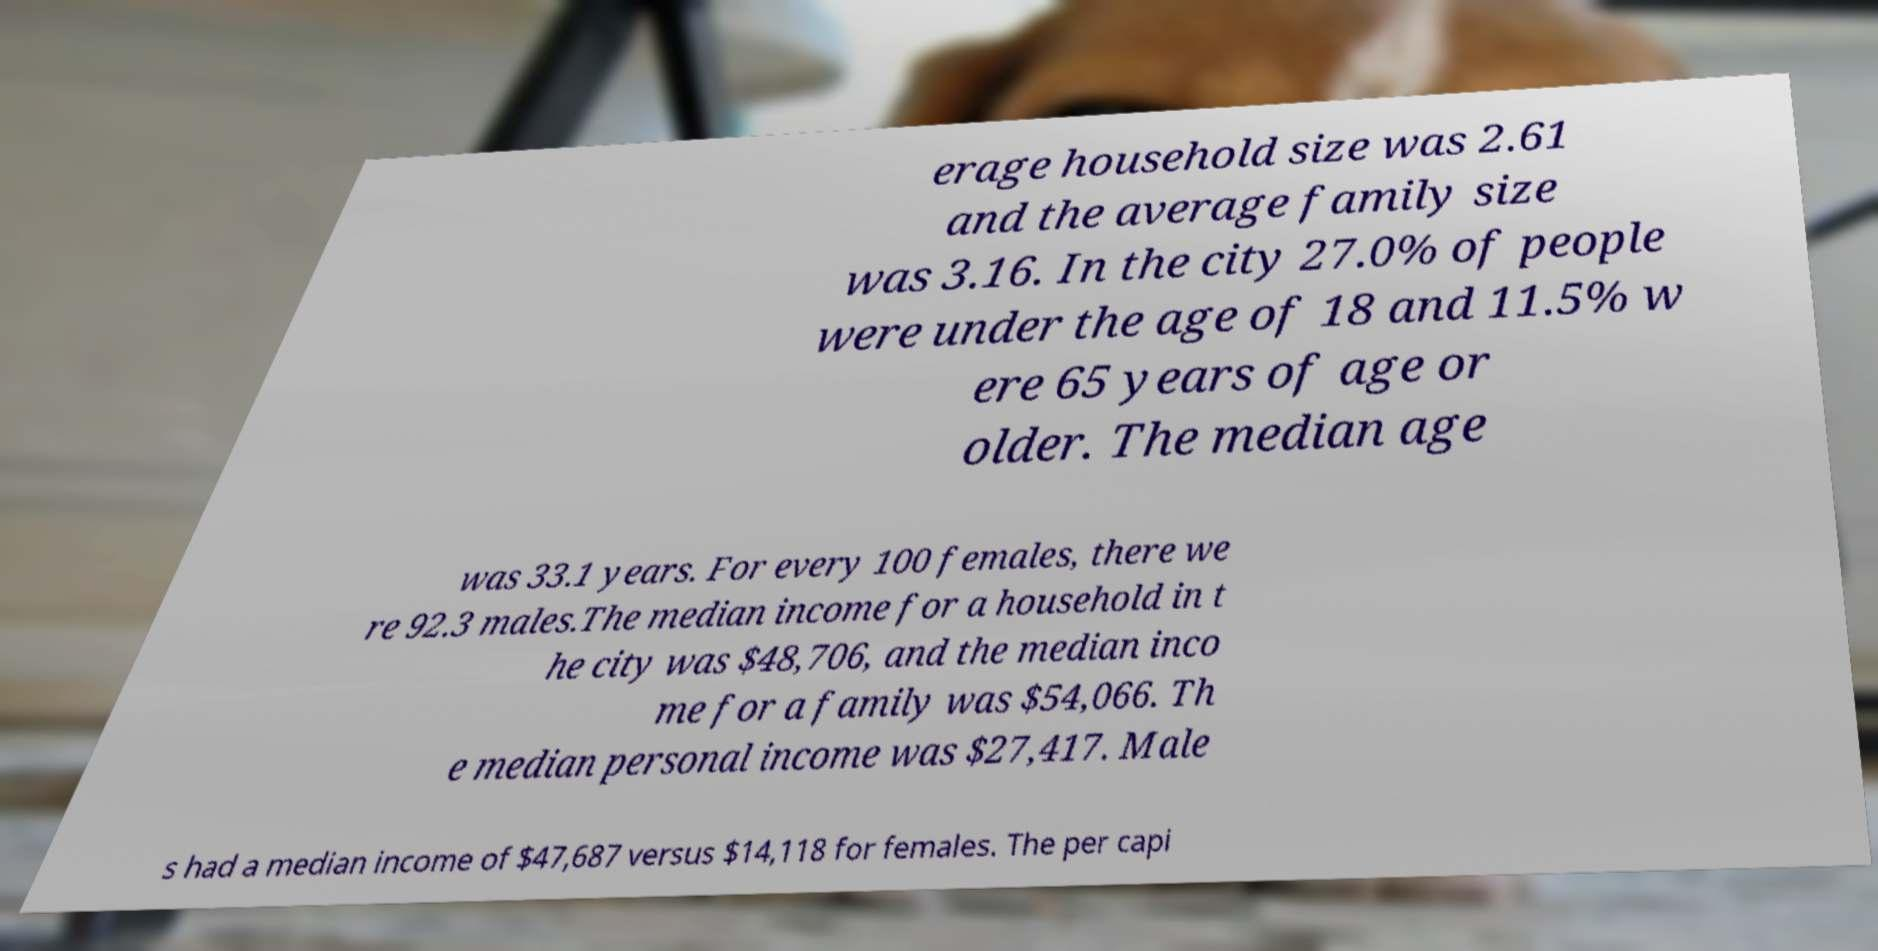What messages or text are displayed in this image? I need them in a readable, typed format. erage household size was 2.61 and the average family size was 3.16. In the city 27.0% of people were under the age of 18 and 11.5% w ere 65 years of age or older. The median age was 33.1 years. For every 100 females, there we re 92.3 males.The median income for a household in t he city was $48,706, and the median inco me for a family was $54,066. Th e median personal income was $27,417. Male s had a median income of $47,687 versus $14,118 for females. The per capi 